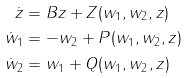<formula> <loc_0><loc_0><loc_500><loc_500>\dot { z } & = B z + Z ( w _ { 1 } , w _ { 2 } , z ) \\ \dot { w } _ { 1 } & = - w _ { 2 } + P ( w _ { 1 } , w _ { 2 } , z ) \\ \dot { w } _ { 2 } & = w _ { 1 } + Q ( w _ { 1 } , w _ { 2 } , z )</formula> 